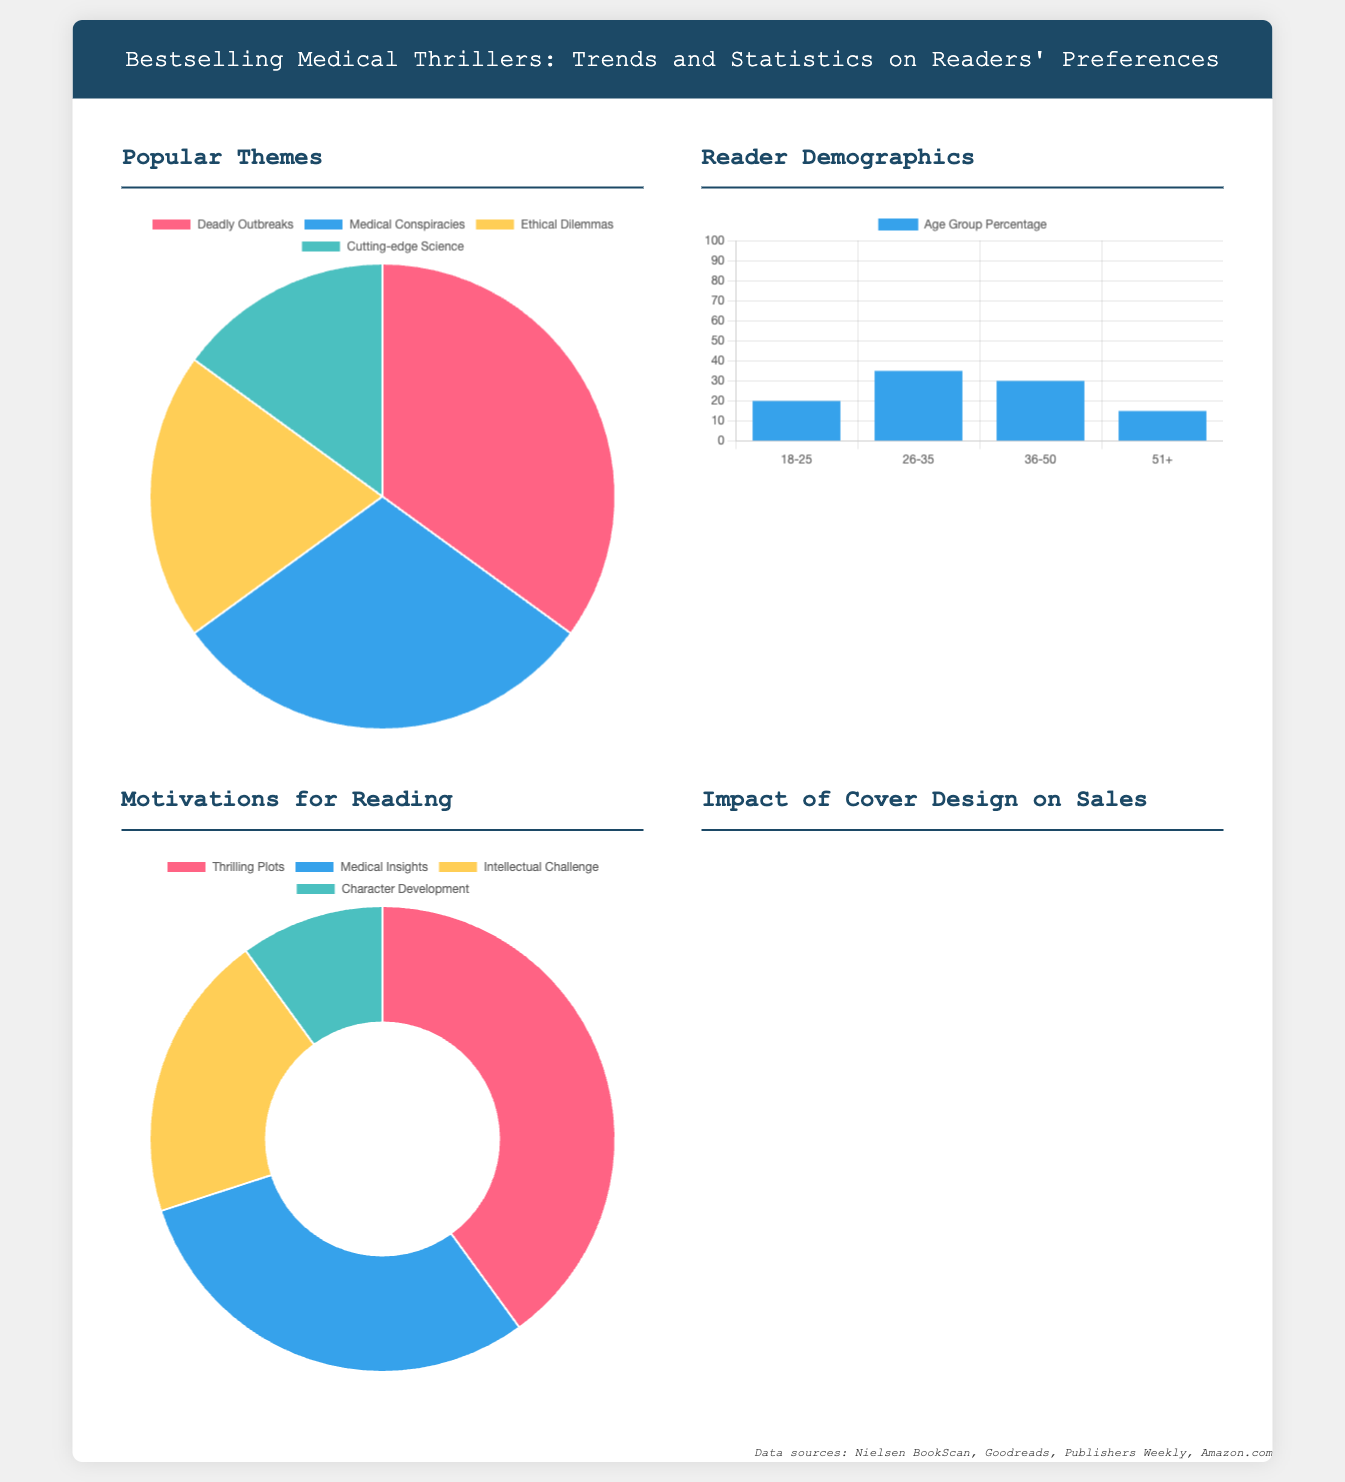What is the most popular theme in medical thrillers? The most popular theme is indicated in the pie chart as representing the highest percentage of readers' preferences.
Answer: Deadly Outbreaks What percentage of readers falls within the 26-35 age group? The bar chart clearly shows the percentage of readers by age group, specifically for the 26-35 range.
Answer: 35 What is the least motivating factor for reading medical thrillers? The doughnut chart displays various motivations for reading; the one with the smallest percentage represents the least motivating factor.
Answer: Character Development What impact percentage does visual appeal have on sales? The horizontal bar chart indicates the impact percentage of different aspects of cover design, highlighting the significance of visual appeal.
Answer: 45 What type of chart illustrates popular themes in medical thrillers? The type of chart used to depict the popular themes section within the infographic is specified.
Answer: Pie Chart Which demographic has the highest percentage of readers? The bar chart identifies the age group with the largest portion of readers, revealing the most prevalent demographic.
Answer: 26-35 What is the second most popular motivation for reading? The data visualizations classify motivations and indicate the rankings of each, allowing us to find the second highest.
Answer: Medical Insights What percentage do author recognition covers impact sales? The horizontal bar chart presents the impact percentages for different cover design elements, revealing the specific figure for author recognition.
Answer: 30 